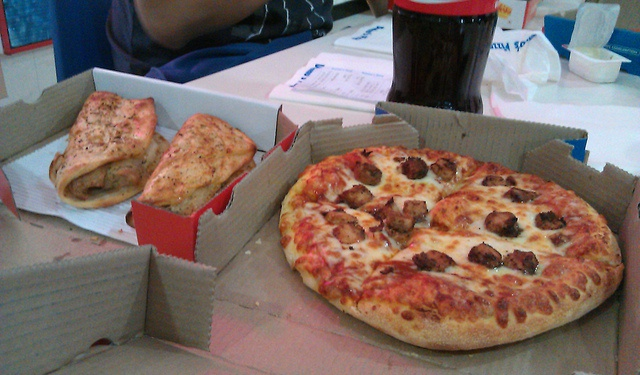Describe the objects in this image and their specific colors. I can see pizza in brown, maroon, and tan tones, dining table in brown, lavender, lightblue, and darkgray tones, people in brown, black, navy, and maroon tones, bottle in brown, black, and gray tones, and chair in brown, navy, black, and blue tones in this image. 